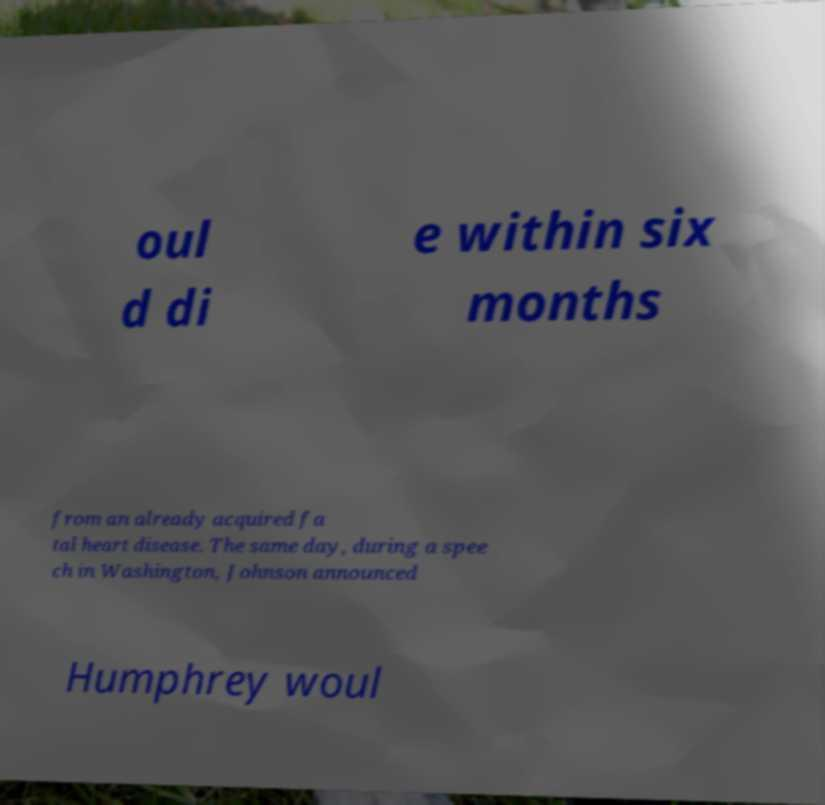Could you extract and type out the text from this image? oul d di e within six months from an already acquired fa tal heart disease. The same day, during a spee ch in Washington, Johnson announced Humphrey woul 